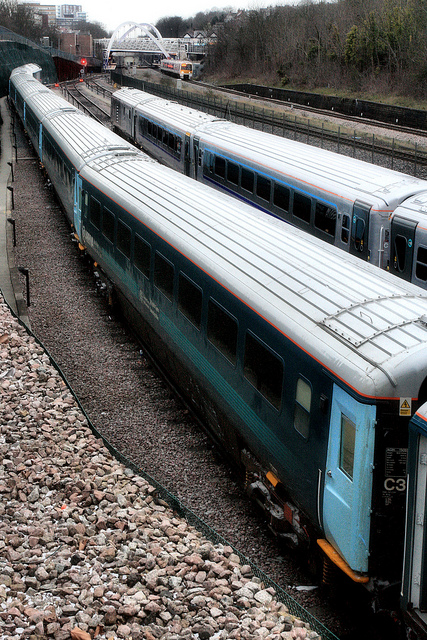Identify and read out the text in this image. C3 